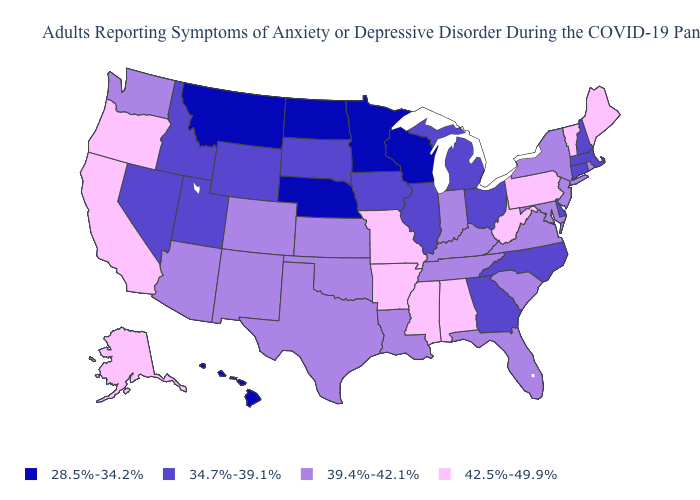Name the states that have a value in the range 39.4%-42.1%?
Keep it brief. Arizona, Colorado, Florida, Indiana, Kansas, Kentucky, Louisiana, Maryland, New Jersey, New Mexico, New York, Oklahoma, Rhode Island, South Carolina, Tennessee, Texas, Virginia, Washington. What is the value of Maine?
Answer briefly. 42.5%-49.9%. What is the lowest value in the West?
Short answer required. 28.5%-34.2%. How many symbols are there in the legend?
Write a very short answer. 4. What is the highest value in the USA?
Short answer required. 42.5%-49.9%. What is the lowest value in states that border Iowa?
Quick response, please. 28.5%-34.2%. Which states have the lowest value in the Northeast?
Answer briefly. Connecticut, Massachusetts, New Hampshire. Does the map have missing data?
Write a very short answer. No. What is the highest value in the USA?
Quick response, please. 42.5%-49.9%. What is the value of Kansas?
Write a very short answer. 39.4%-42.1%. Name the states that have a value in the range 39.4%-42.1%?
Write a very short answer. Arizona, Colorado, Florida, Indiana, Kansas, Kentucky, Louisiana, Maryland, New Jersey, New Mexico, New York, Oklahoma, Rhode Island, South Carolina, Tennessee, Texas, Virginia, Washington. Does New York have the same value as Maryland?
Short answer required. Yes. How many symbols are there in the legend?
Keep it brief. 4. How many symbols are there in the legend?
Concise answer only. 4. Which states hav the highest value in the West?
Concise answer only. Alaska, California, Oregon. 